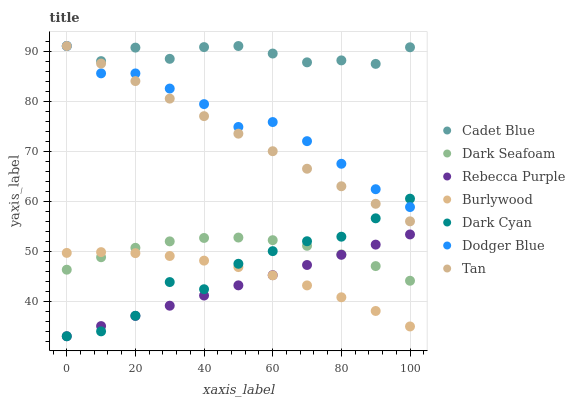Does Rebecca Purple have the minimum area under the curve?
Answer yes or no. Yes. Does Cadet Blue have the maximum area under the curve?
Answer yes or no. Yes. Does Burlywood have the minimum area under the curve?
Answer yes or no. No. Does Burlywood have the maximum area under the curve?
Answer yes or no. No. Is Rebecca Purple the smoothest?
Answer yes or no. Yes. Is Dark Cyan the roughest?
Answer yes or no. Yes. Is Burlywood the smoothest?
Answer yes or no. No. Is Burlywood the roughest?
Answer yes or no. No. Does Rebecca Purple have the lowest value?
Answer yes or no. Yes. Does Burlywood have the lowest value?
Answer yes or no. No. Does Tan have the highest value?
Answer yes or no. Yes. Does Dark Seafoam have the highest value?
Answer yes or no. No. Is Rebecca Purple less than Dodger Blue?
Answer yes or no. Yes. Is Dodger Blue greater than Burlywood?
Answer yes or no. Yes. Does Dark Cyan intersect Tan?
Answer yes or no. Yes. Is Dark Cyan less than Tan?
Answer yes or no. No. Is Dark Cyan greater than Tan?
Answer yes or no. No. Does Rebecca Purple intersect Dodger Blue?
Answer yes or no. No. 